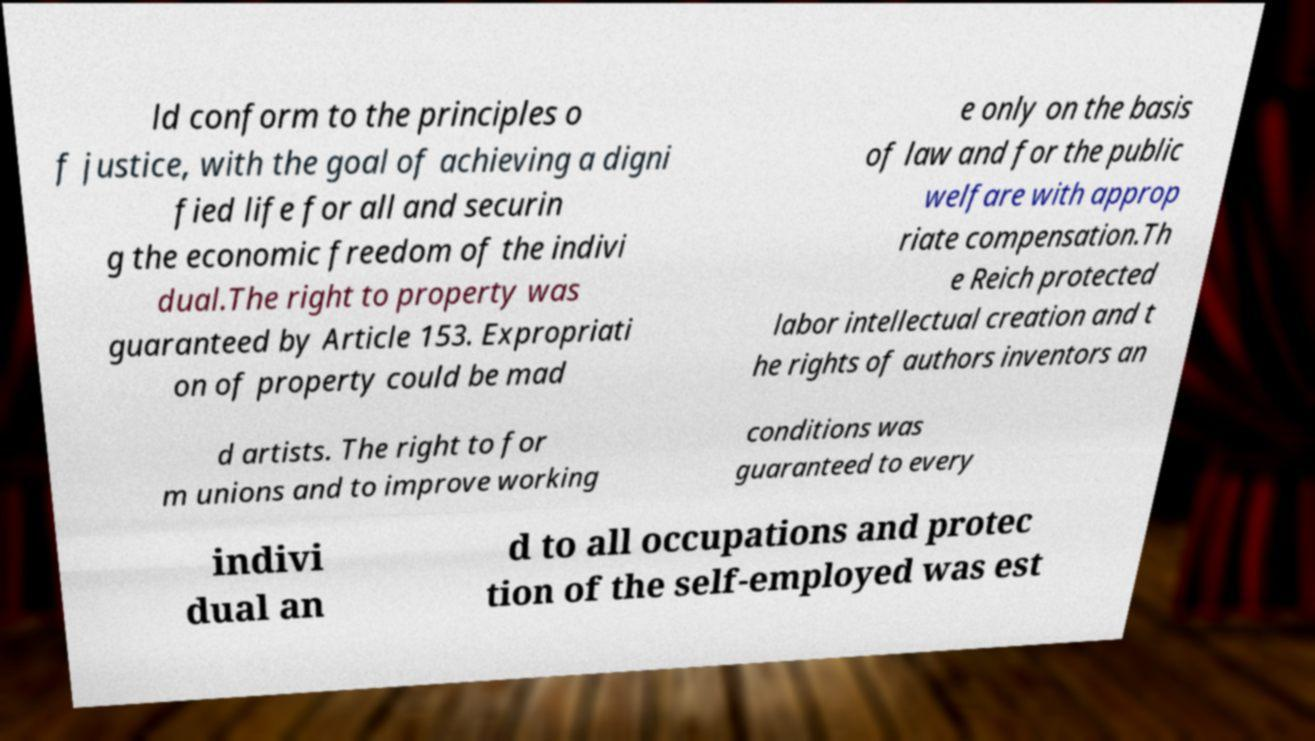Could you assist in decoding the text presented in this image and type it out clearly? ld conform to the principles o f justice, with the goal of achieving a digni fied life for all and securin g the economic freedom of the indivi dual.The right to property was guaranteed by Article 153. Expropriati on of property could be mad e only on the basis of law and for the public welfare with approp riate compensation.Th e Reich protected labor intellectual creation and t he rights of authors inventors an d artists. The right to for m unions and to improve working conditions was guaranteed to every indivi dual an d to all occupations and protec tion of the self-employed was est 